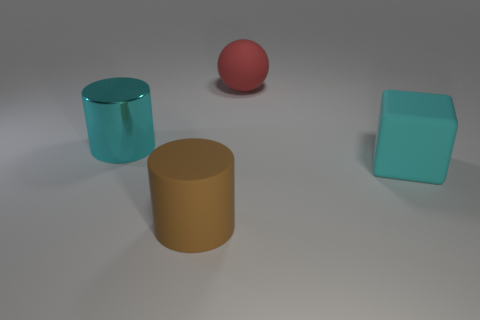Add 2 big matte cylinders. How many objects exist? 6 Subtract all cyan rubber spheres. Subtract all large objects. How many objects are left? 0 Add 1 rubber cubes. How many rubber cubes are left? 2 Add 4 small brown metal balls. How many small brown metal balls exist? 4 Subtract 0 gray blocks. How many objects are left? 4 Subtract all cubes. How many objects are left? 3 